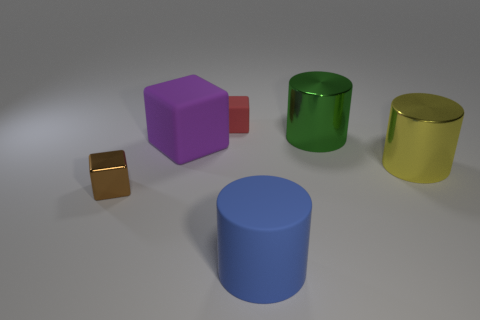What shape is the thing that is to the right of the brown metallic block and to the left of the small red thing?
Keep it short and to the point. Cube. There is a metallic thing that is to the left of the large blue object; does it have the same size as the rubber block that is in front of the red cube?
Offer a very short reply. No. The purple object that is made of the same material as the tiny red thing is what shape?
Offer a very short reply. Cube. Is there anything else that is the same shape as the blue rubber thing?
Your answer should be very brief. Yes. The small object that is on the right side of the shiny object that is on the left side of the large metal object behind the big matte cube is what color?
Provide a succinct answer. Red. Is the number of metal objects that are to the right of the large blue rubber cylinder less than the number of big matte cylinders that are on the left side of the tiny metal object?
Your response must be concise. No. Is the shape of the purple thing the same as the large green metal thing?
Your answer should be very brief. No. What number of purple objects have the same size as the green metal cylinder?
Give a very brief answer. 1. Is the number of green metallic things that are left of the tiny red matte thing less than the number of tiny gray metallic balls?
Keep it short and to the point. No. There is a metallic thing left of the large rubber thing in front of the big purple object; what is its size?
Provide a succinct answer. Small. 